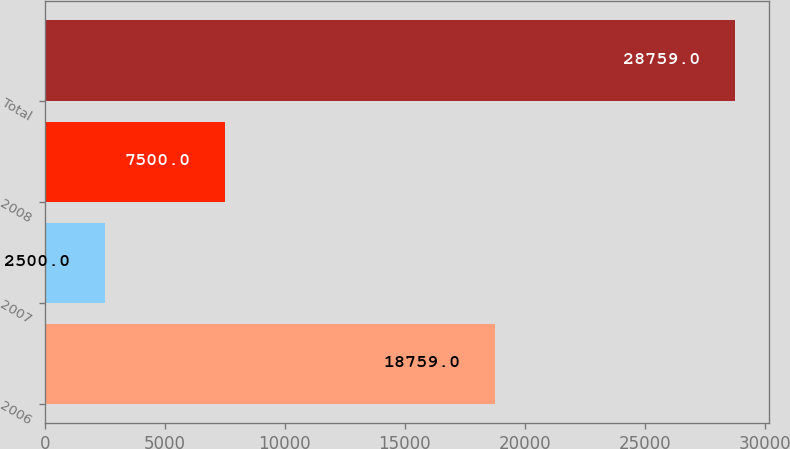<chart> <loc_0><loc_0><loc_500><loc_500><bar_chart><fcel>2006<fcel>2007<fcel>2008<fcel>Total<nl><fcel>18759<fcel>2500<fcel>7500<fcel>28759<nl></chart> 